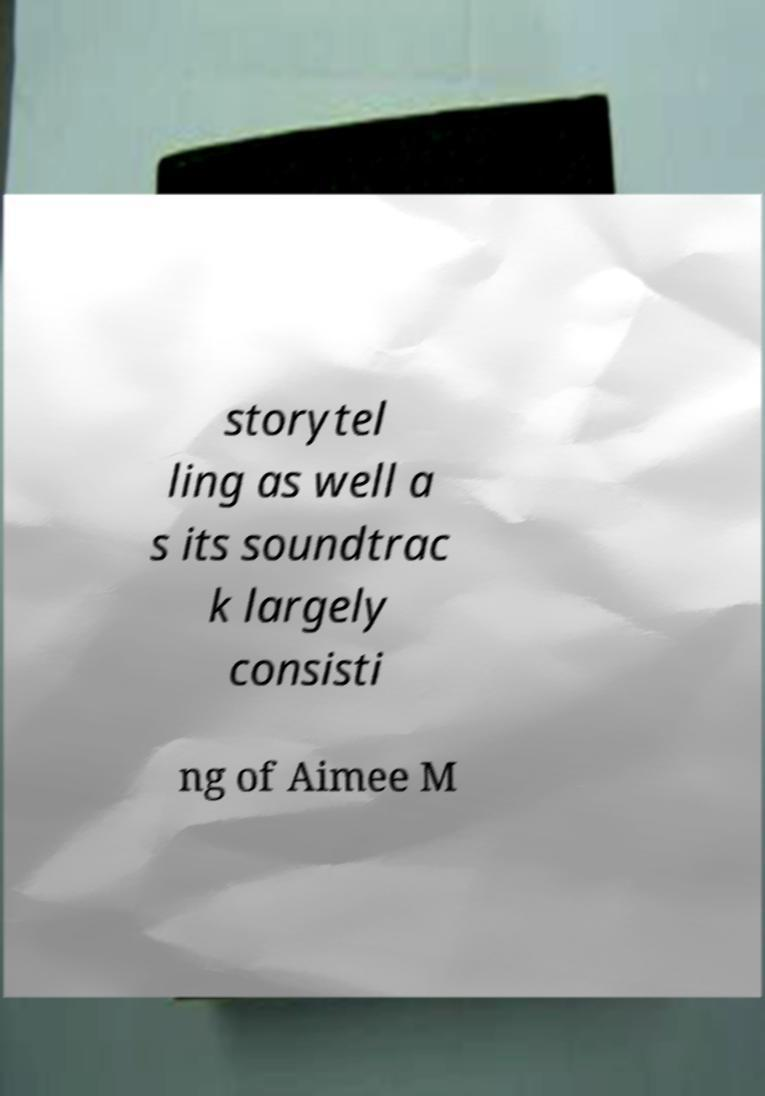Please identify and transcribe the text found in this image. storytel ling as well a s its soundtrac k largely consisti ng of Aimee M 